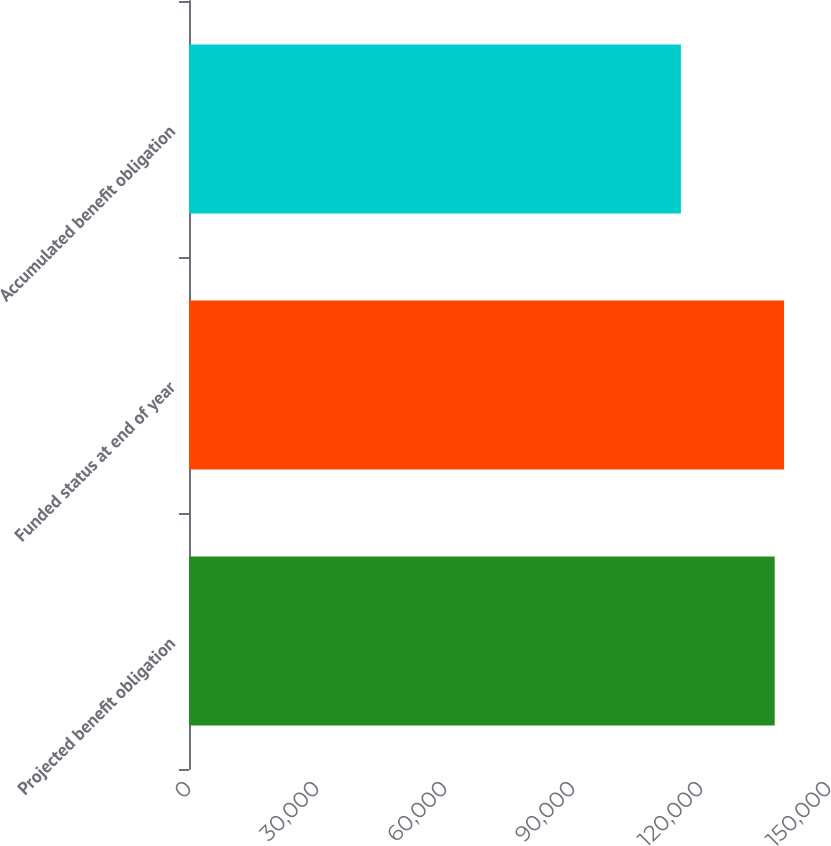<chart> <loc_0><loc_0><loc_500><loc_500><bar_chart><fcel>Projected benefit obligation<fcel>Funded status at end of year<fcel>Accumulated benefit obligation<nl><fcel>137271<fcel>139470<fcel>115286<nl></chart> 